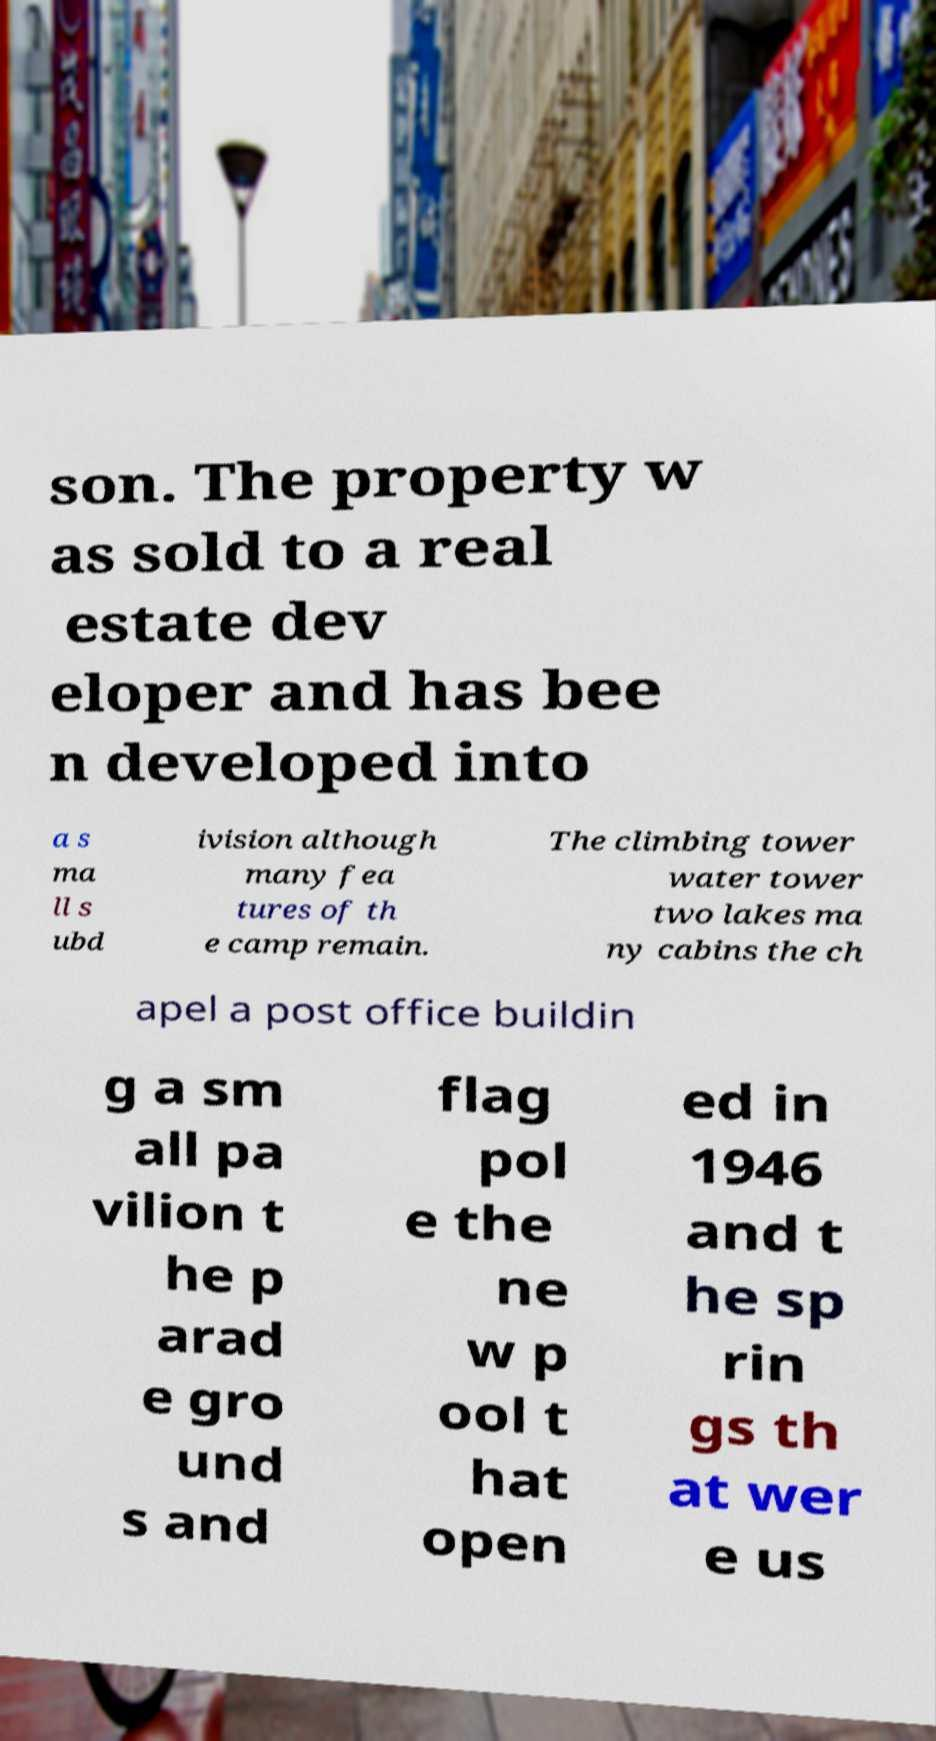Could you assist in decoding the text presented in this image and type it out clearly? son. The property w as sold to a real estate dev eloper and has bee n developed into a s ma ll s ubd ivision although many fea tures of th e camp remain. The climbing tower water tower two lakes ma ny cabins the ch apel a post office buildin g a sm all pa vilion t he p arad e gro und s and flag pol e the ne w p ool t hat open ed in 1946 and t he sp rin gs th at wer e us 